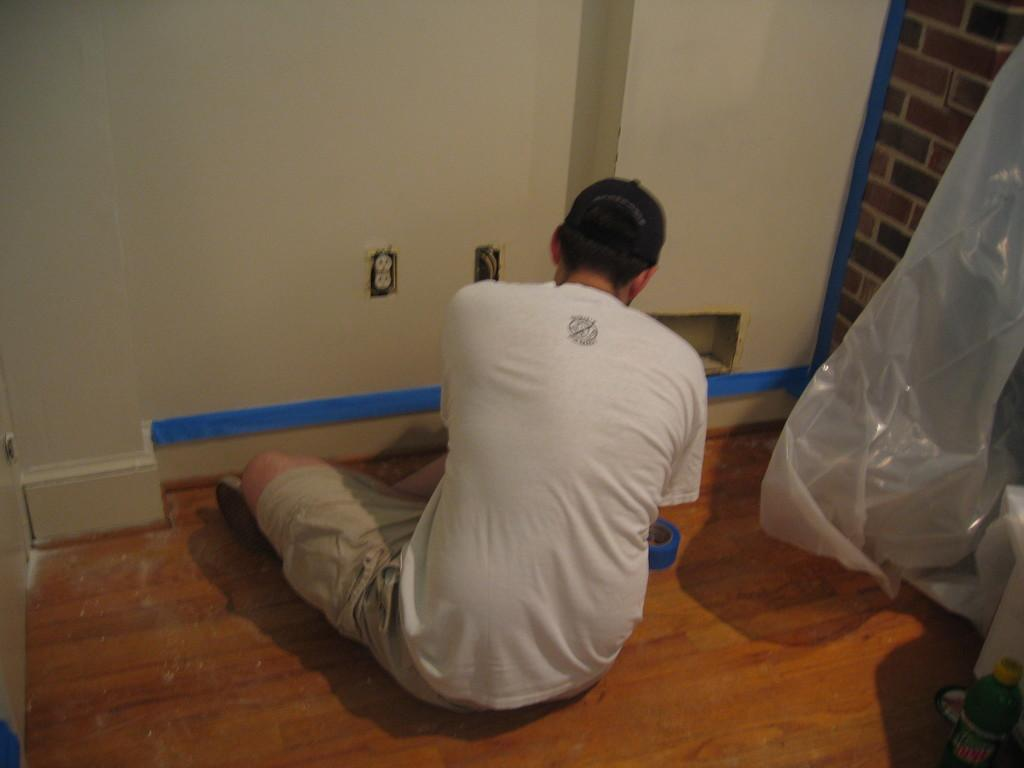What is one of the main features in the image? There is a wall in the image. What else can be seen in the image? There is a cover in the image. Can you describe the person in the image? The person in the image is wearing a white t-shirt. How many snakes are wrapped around the person's legs in the image? There are no snakes present in the image. What type of sweater is the person wearing in the image? The person is not wearing a sweater in the image; they are wearing a white t-shirt. 